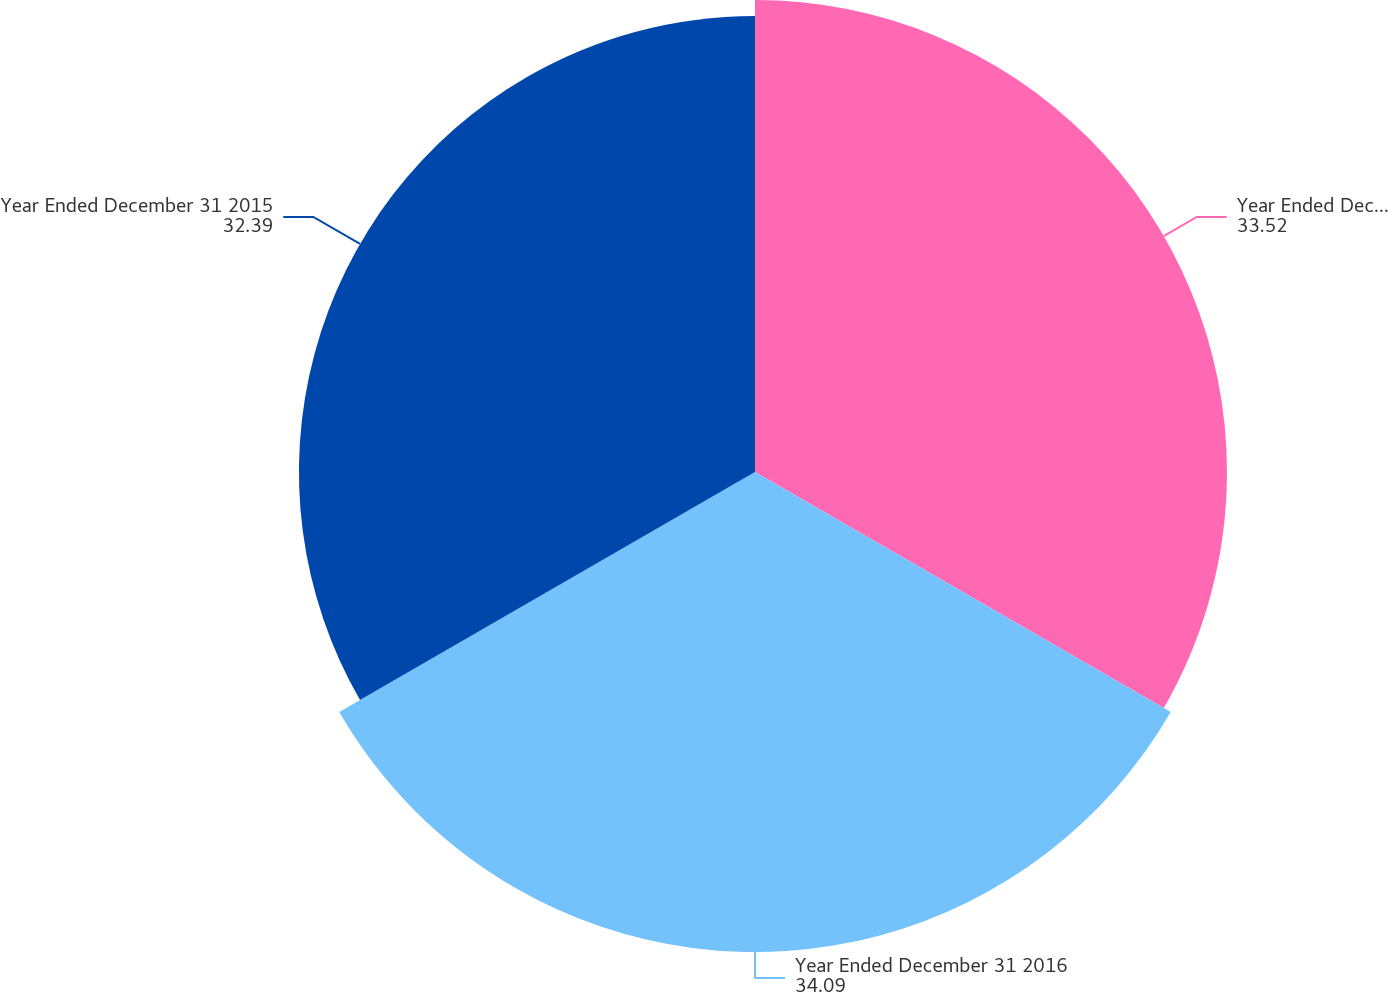Convert chart. <chart><loc_0><loc_0><loc_500><loc_500><pie_chart><fcel>Year Ended December 31 2017<fcel>Year Ended December 31 2016<fcel>Year Ended December 31 2015<nl><fcel>33.52%<fcel>34.09%<fcel>32.39%<nl></chart> 